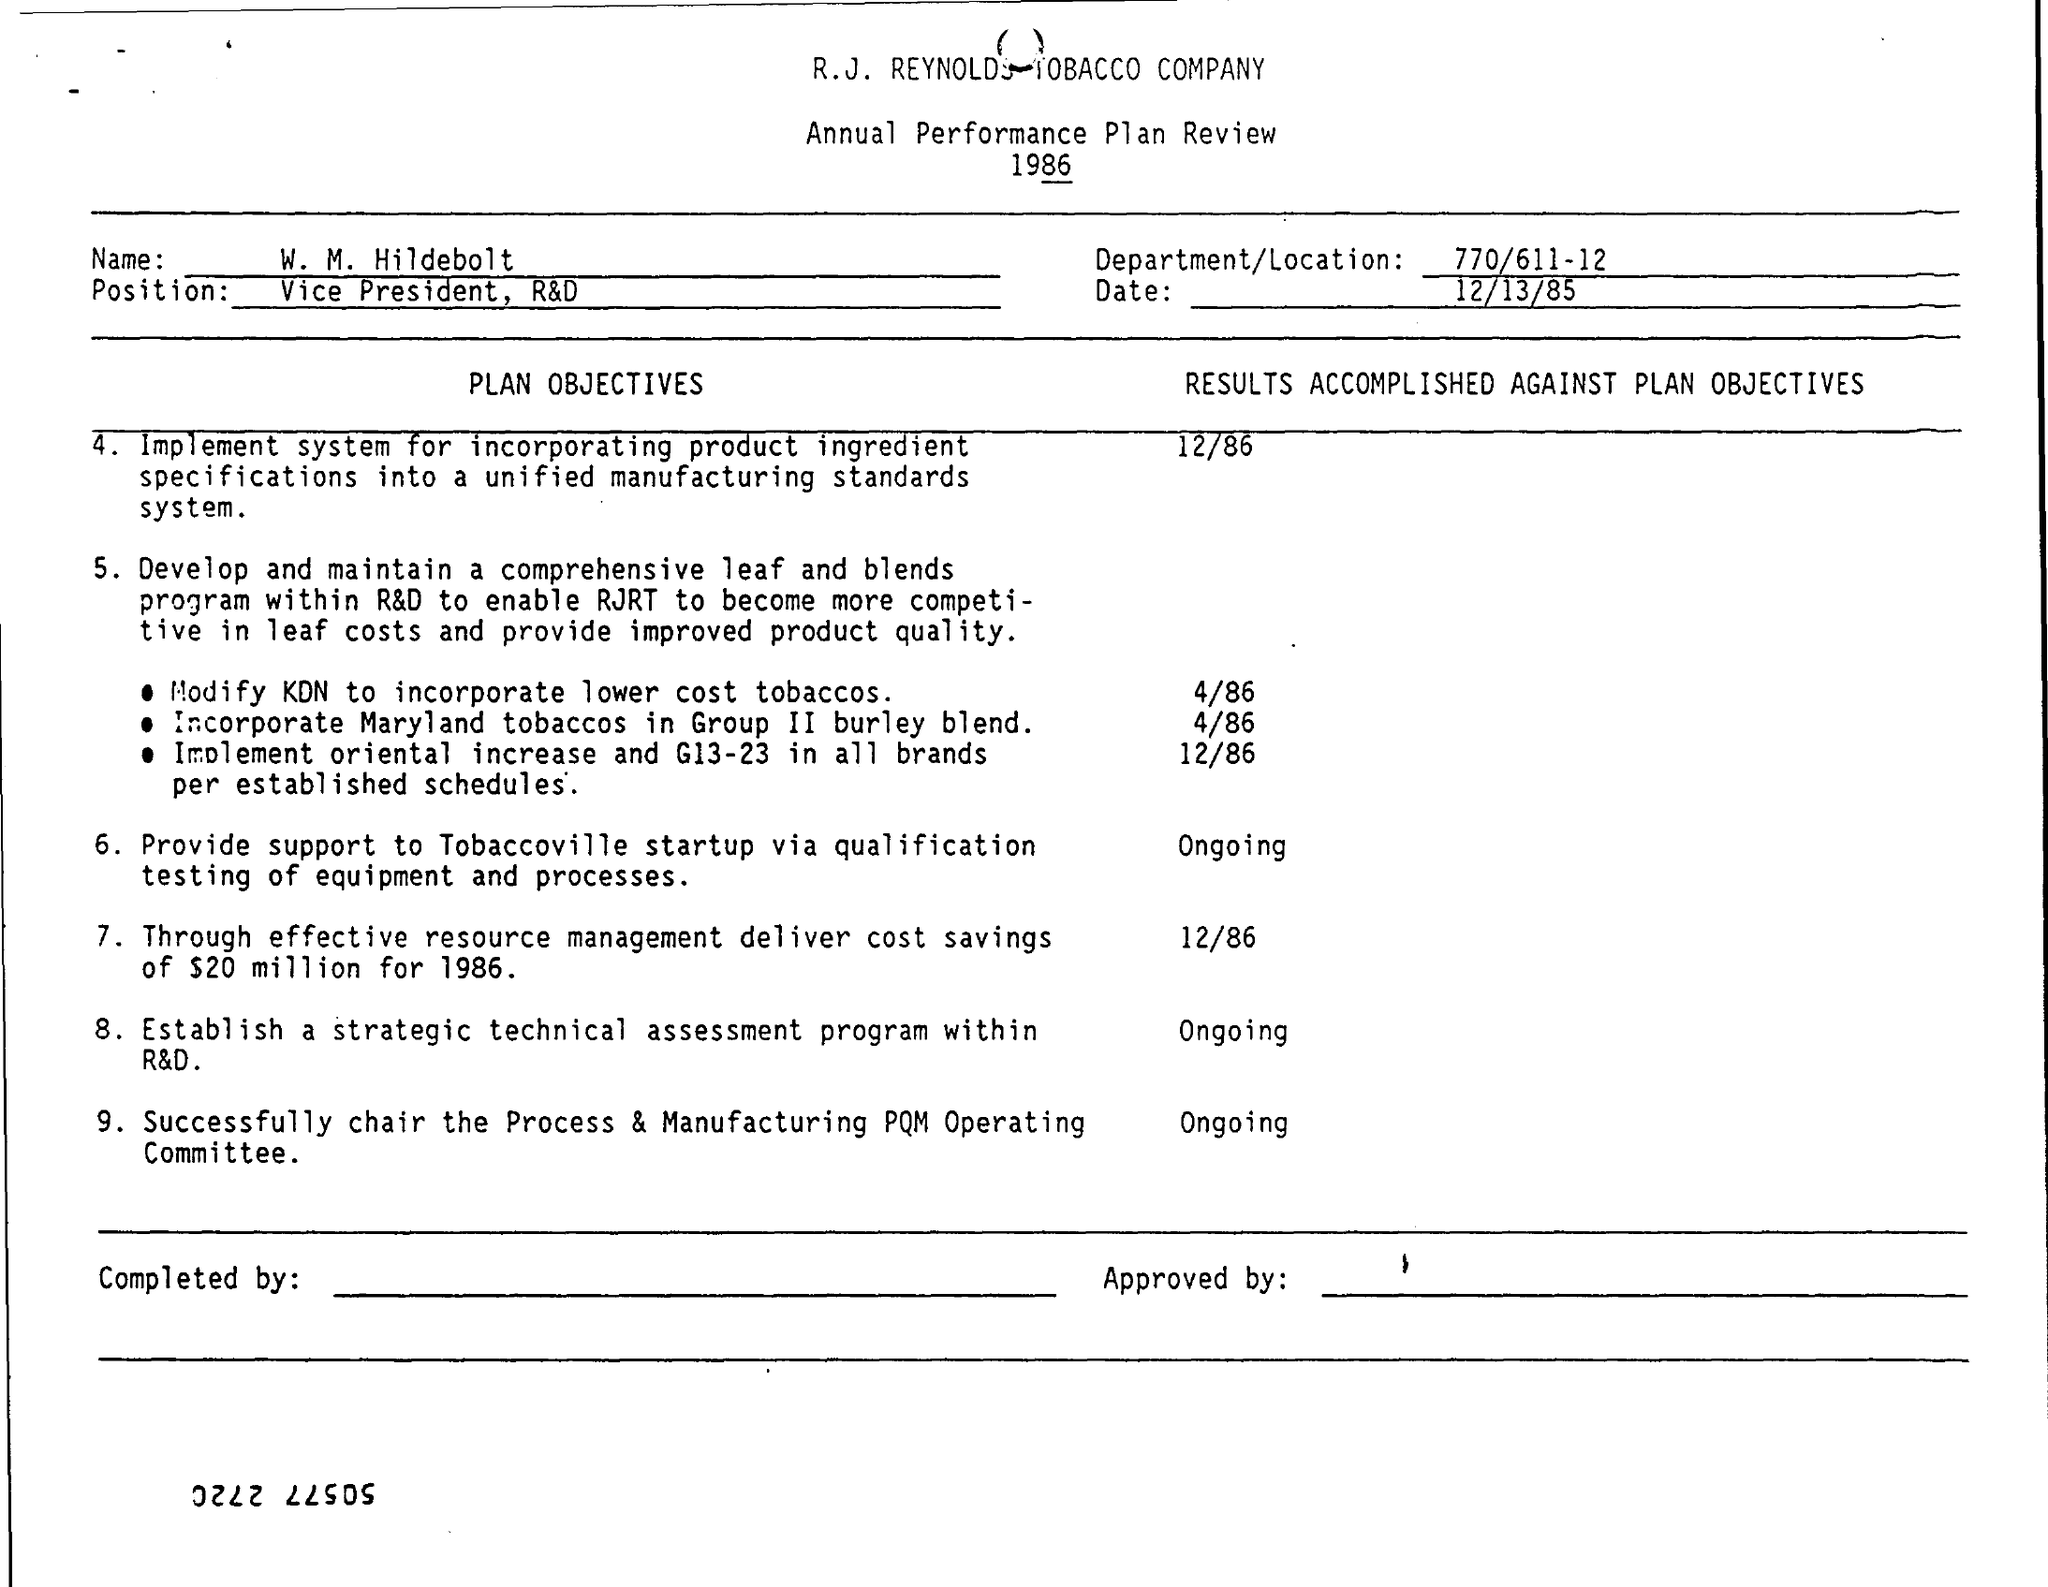What is the name of the company mentioned in the plan review?
Make the answer very short. R.J.REYNOLDS TOBACCO COMPANY. What is the designation of w.m. hildebolt ?
Offer a very short reply. Vice president ,r&d. What is the department/location mentioned in the plan review ?
Offer a very short reply. 770/611-12. What is the date mentioned in the plan review ?
Keep it short and to the point. 12/13/85. On which date the results accomplished against modify kdn to incorporate lower cost tobaccos ?
Provide a short and direct response. 4/86. On which date the results accomplished against incorporate maryland tobaccos in group burley blend ?
Give a very brief answer. 4/86. On which date the results accomplished against establish  a strategic technical assessment program within r&d ?
Give a very brief answer. ONGOING. 